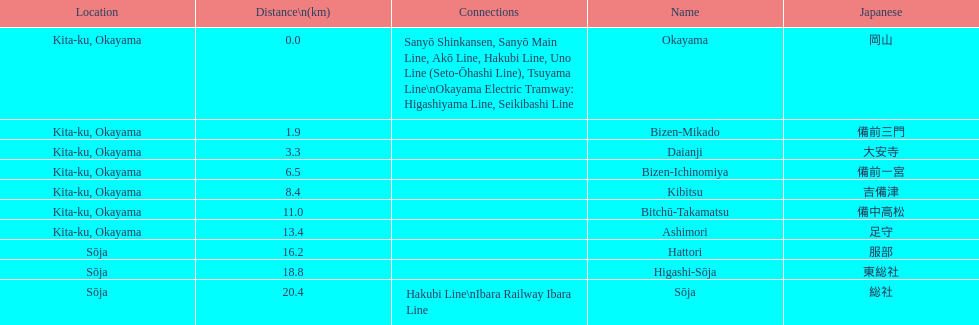Which has a distance of more than 1 kilometer but less than 2 kilometers? Bizen-Mikado. 